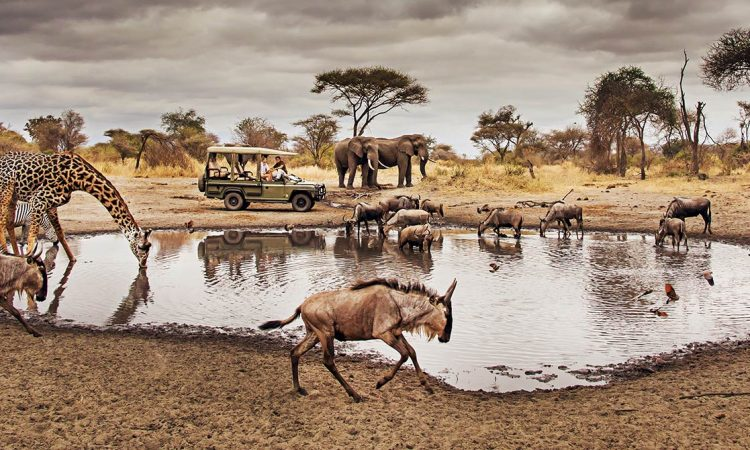Can you tell me more about the different species visible in this photo? Certainly! In this image we see a diverse representation of African savannah wildlife. A tall giraffe is notable for its towering height and patterned fur. A collective of elephants are seen in the midground, recognizable by their large ears and trunks—they are likely a family group. Meanwhile, wildebeest with their sloped backs and curved horns are scattered about, a common sighting in these regions due to their large migratory herds. The scene is a microcosm of the savannah ecosystem, each species playing a role in maintaining the balance of their environment. What does this gathering around the watering hole tell us about the animals' behavior? The watering hole is a central point of convergence for different species within the African savannah. It's a place where animals can hydrate, which is essential for their survival, especially in an environment where water can be scarce. Gathering at this spot also presents opportunities for social interactions between herd members and between different species as well. The presence of so many animals at once can indicate that this is either a time of day when animals typically come to drink or it's a period when water is particularly scarce elsewhere, thus highlighting the importance of such habitats. 